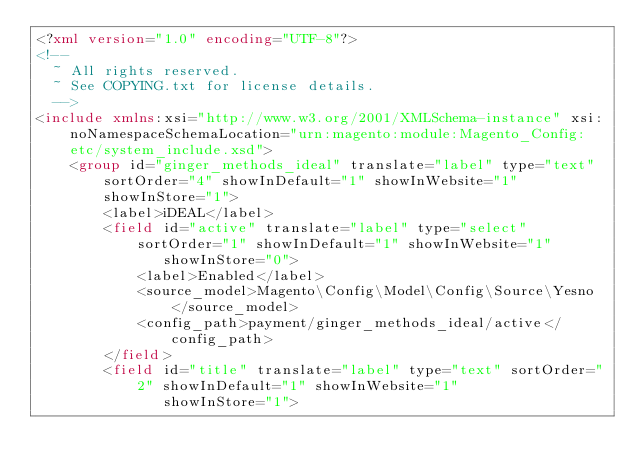Convert code to text. <code><loc_0><loc_0><loc_500><loc_500><_XML_><?xml version="1.0" encoding="UTF-8"?>
<!--
  ~ All rights reserved.
  ~ See COPYING.txt for license details.
  -->
<include xmlns:xsi="http://www.w3.org/2001/XMLSchema-instance" xsi:noNamespaceSchemaLocation="urn:magento:module:Magento_Config:etc/system_include.xsd">
    <group id="ginger_methods_ideal" translate="label" type="text" sortOrder="4" showInDefault="1" showInWebsite="1" showInStore="1">
        <label>iDEAL</label>
        <field id="active" translate="label" type="select" sortOrder="1" showInDefault="1" showInWebsite="1"
               showInStore="0">
            <label>Enabled</label>
            <source_model>Magento\Config\Model\Config\Source\Yesno</source_model>
            <config_path>payment/ginger_methods_ideal/active</config_path>
        </field>
        <field id="title" translate="label" type="text" sortOrder="2" showInDefault="1" showInWebsite="1"
               showInStore="1"></code> 